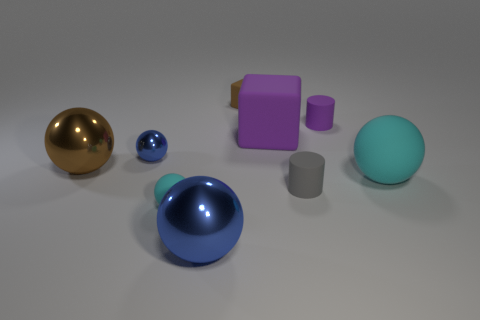What number of small balls are there?
Your answer should be compact. 2. There is a matte object that is to the left of the large purple rubber object and in front of the tiny purple object; what is its size?
Your response must be concise. Small. There is a purple matte thing that is the same size as the brown metallic sphere; what shape is it?
Provide a succinct answer. Cube. Are there any big shiny spheres that are in front of the cyan matte sphere that is to the right of the purple cylinder?
Offer a very short reply. Yes. The other rubber object that is the same shape as the tiny gray matte object is what color?
Keep it short and to the point. Purple. There is a large matte object on the right side of the tiny purple rubber cylinder; is its color the same as the small rubber block?
Keep it short and to the point. No. What number of things are shiny spheres that are to the left of the tiny cyan ball or cylinders?
Your answer should be very brief. 4. There is a small cylinder in front of the cyan object that is to the right of the tiny matte cylinder that is behind the small blue ball; what is its material?
Offer a very short reply. Rubber. Are there more large blocks behind the tiny block than tiny cubes that are behind the big purple matte cube?
Ensure brevity in your answer.  No. How many cylinders are either large shiny objects or tiny brown rubber things?
Make the answer very short. 0. 